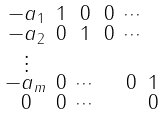Convert formula to latex. <formula><loc_0><loc_0><loc_500><loc_500>\begin{smallmatrix} - a _ { 1 } & 1 & 0 & 0 & \cdots \\ - a _ { 2 } & 0 & 1 & 0 & \cdots \\ \vdots \\ - a _ { m } & 0 & \cdots & & 0 & 1 \\ 0 & 0 & \cdots & & & 0 \end{smallmatrix}</formula> 